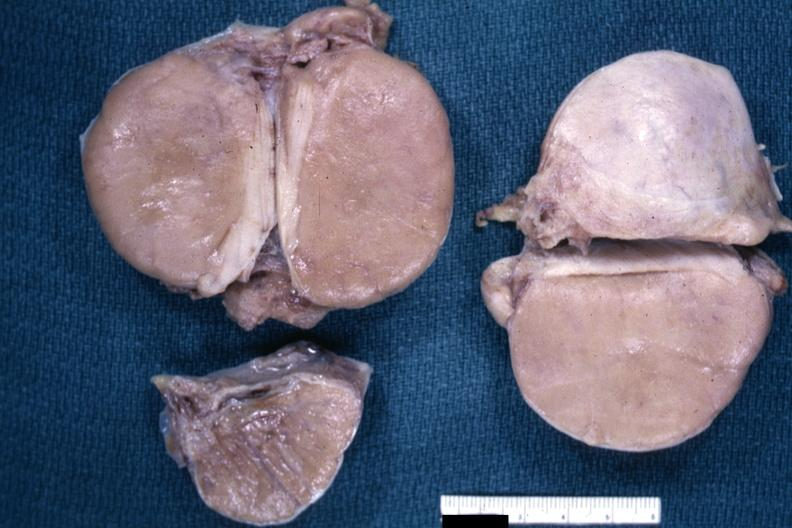what is present?
Answer the question using a single word or phrase. Malignant lymphoma 